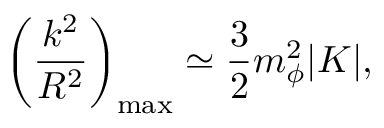Convert formula to latex. <formula><loc_0><loc_0><loc_500><loc_500>\left ( \frac { k ^ { 2 } } { R ^ { 2 } } \right ) _ { \max } \simeq \frac { 3 } { 2 } m _ { \phi } ^ { 2 } | K | ,</formula> 